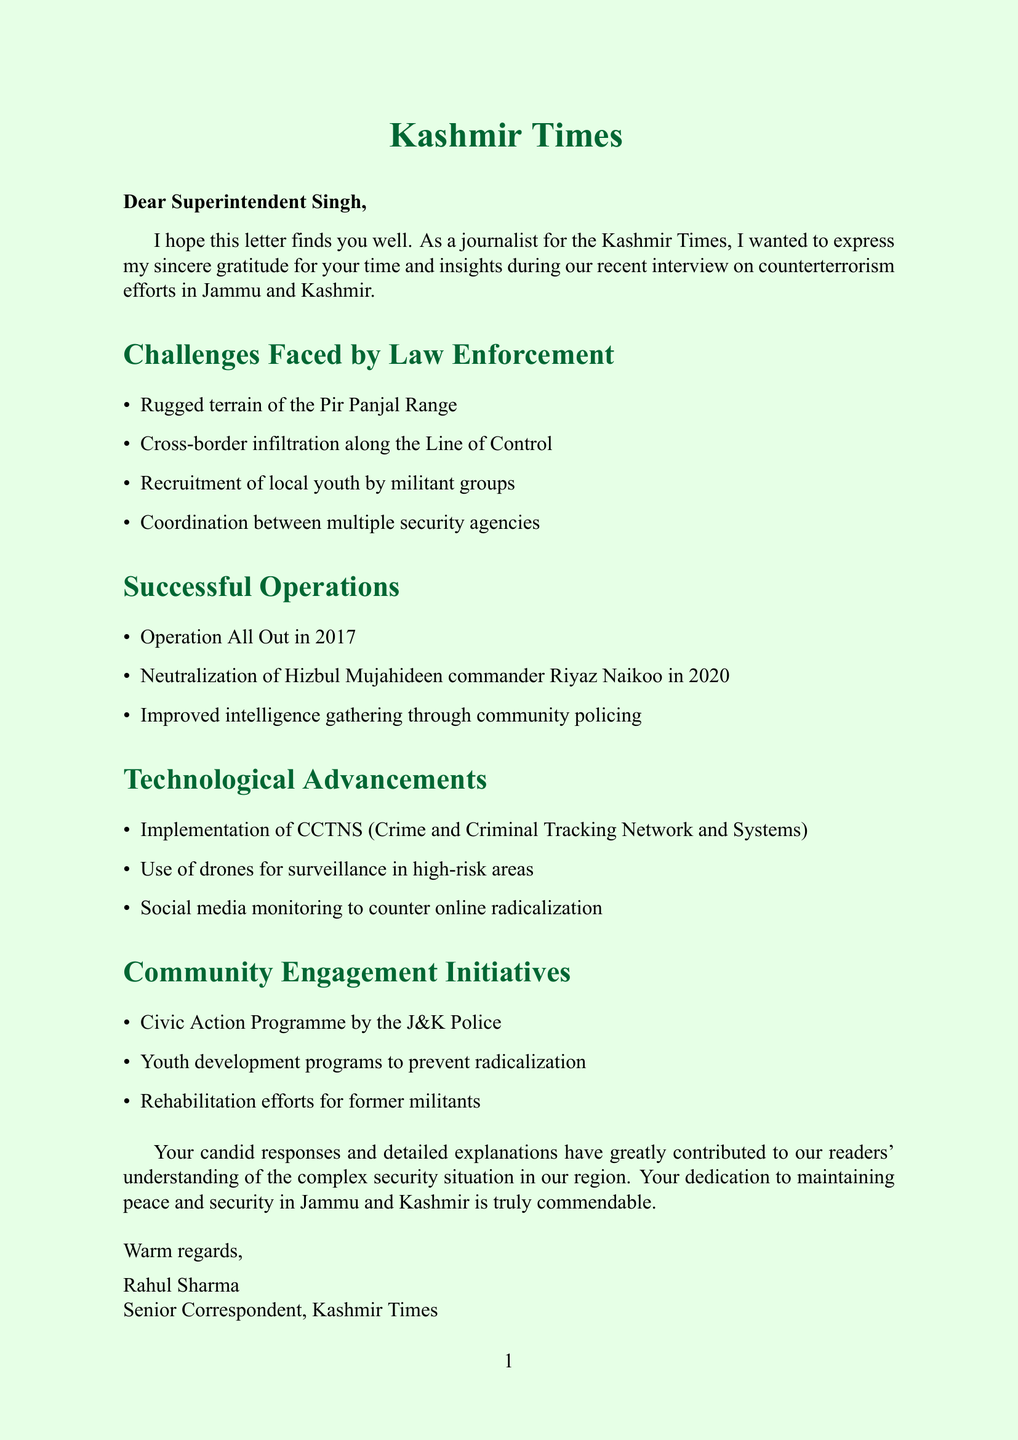What is the name of the recipient of the letter? The letter is addressed to Superintendent Singh.
Answer: Superintendent Singh What is the primary focus of gratitude expressed in the letter? The letter expresses gratitude for insights during an interview on counterterrorism efforts.
Answer: Counterterrorism efforts Which operation is mentioned as being conducted in 2017? The letter states that Operation All Out was conducted in 2017.
Answer: Operation All Out What technological system was implemented for tracking in the region? The document mentions the implementation of CCTNS for tracking purposes.
Answer: CCTNS What significant event occurred in April 2023? The letter refers to an encounter that resulted in the elimination of two LeT militants in April 2023.
Answer: Encounter in Anantnag district Which community engagement initiative is discussed in the letter? The letter discusses the Civic Action Programme by the J&K Police as a community engagement initiative.
Answer: Civic Action Programme What challenge is associated with the terrain in the region? The letter notes the rugged terrain of the Pir Panjal Range as a challenge.
Answer: Rugged terrain of the Pir Panjal Range Who is the sender of the letter? The letter is signed by Rahul Sharma, identified as the Senior Correspondent.
Answer: Rahul Sharma What does the letter commend Superintendent Singh for? The letter commends Superintendent Singh for his dedication to maintaining peace and security.
Answer: Maintaining peace and security 